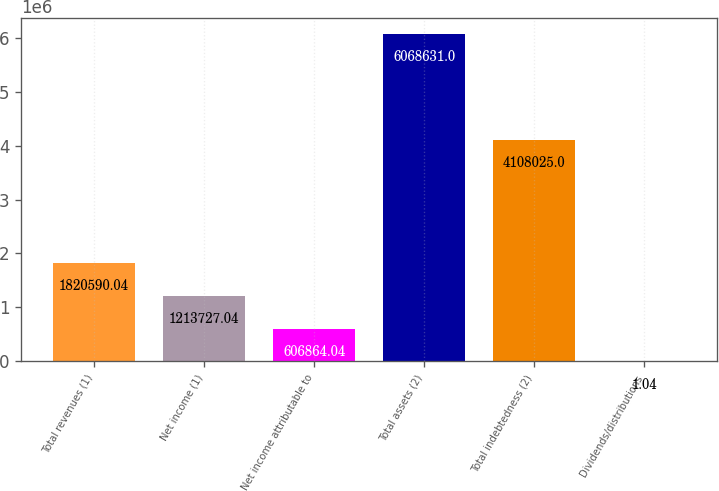Convert chart. <chart><loc_0><loc_0><loc_500><loc_500><bar_chart><fcel>Total revenues (1)<fcel>Net income (1)<fcel>Net income attributable to<fcel>Total assets (2)<fcel>Total indebtedness (2)<fcel>Dividends/distributions<nl><fcel>1.82059e+06<fcel>1.21373e+06<fcel>606864<fcel>6.06863e+06<fcel>4.10802e+06<fcel>1.04<nl></chart> 